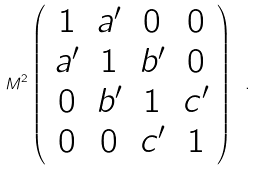Convert formula to latex. <formula><loc_0><loc_0><loc_500><loc_500>M ^ { 2 } \left ( \begin{array} { c c c c } { 1 } & { { a ^ { \prime } } } & { 0 } & { 0 } \\ { { a ^ { \prime } } } & { 1 } & { { b ^ { \prime } } } & { 0 } \\ { 0 } & { { b ^ { \prime } } } & { 1 } & { { c ^ { \prime } } } \\ { 0 } & { 0 } & { { c ^ { \prime } } } & { 1 } \end{array} \right ) \ .</formula> 